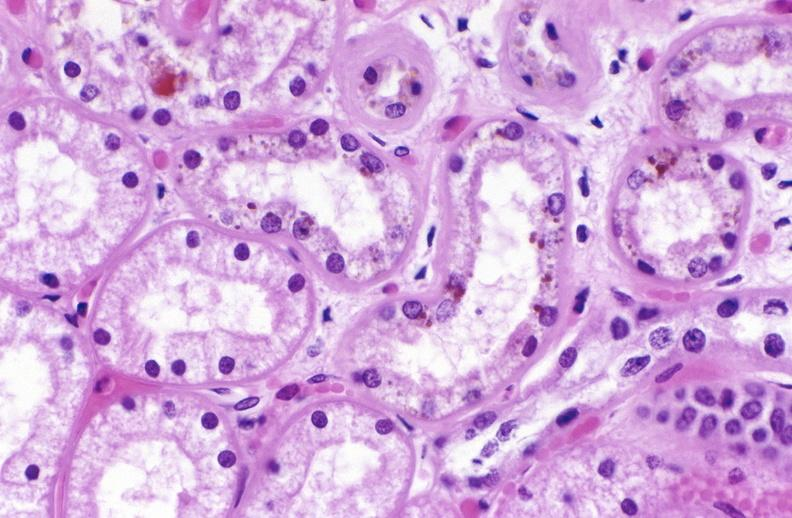does this image show atn and bile pigment?
Answer the question using a single word or phrase. Yes 